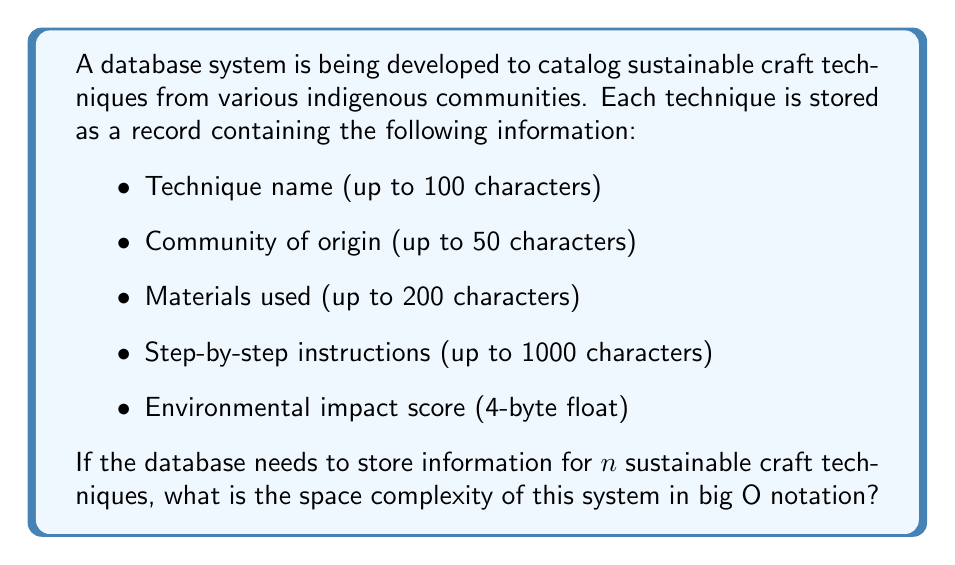Solve this math problem. To determine the space complexity, we need to calculate the total space required for storing $n$ records and express it in terms of $n$.

1. Calculate the space required for each field:
   - Technique name: 100 characters * 1 byte/character = 100 bytes
   - Community of origin: 50 characters * 1 byte/character = 50 bytes
   - Materials used: 200 characters * 1 byte/character = 200 bytes
   - Step-by-step instructions: 1000 characters * 1 byte/character = 1000 bytes
   - Environmental impact score: 4 bytes

2. Sum up the space for all fields in one record:
   $$100 + 50 + 200 + 1000 + 4 = 1354$$ bytes per record

3. Calculate the total space for $n$ records:
   $$1354n$$ bytes

4. Express the space complexity in big O notation:
   The space required grows linearly with the number of records $n$, so the space complexity is $O(n)$.

Note: Constants are dropped in big O notation, so $O(1354n)$ simplifies to $O(n)$.
Answer: $O(n)$ 